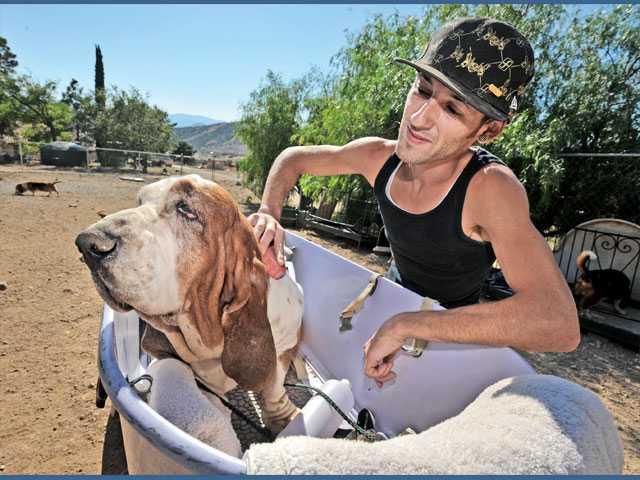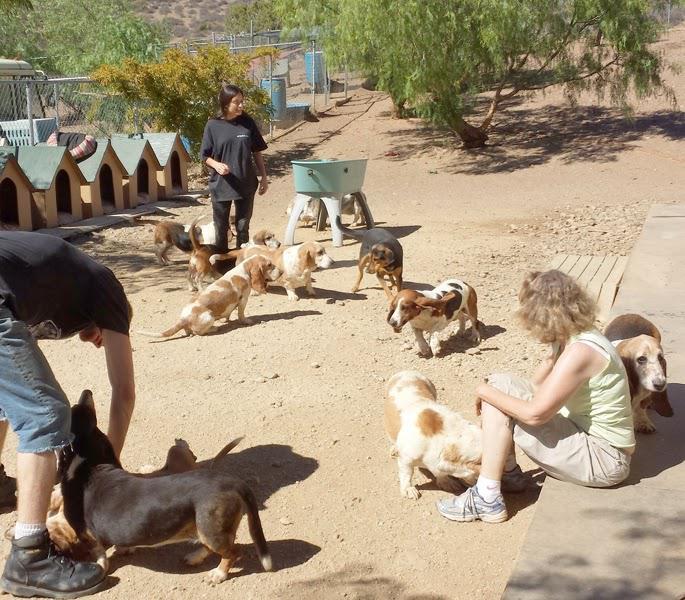The first image is the image on the left, the second image is the image on the right. Given the left and right images, does the statement "A person in a tank top is bathing a dog outside." hold true? Answer yes or no. Yes. The first image is the image on the left, the second image is the image on the right. Assess this claim about the two images: "An image shows a person behind a wash bucket containing a basset hound.". Correct or not? Answer yes or no. Yes. 